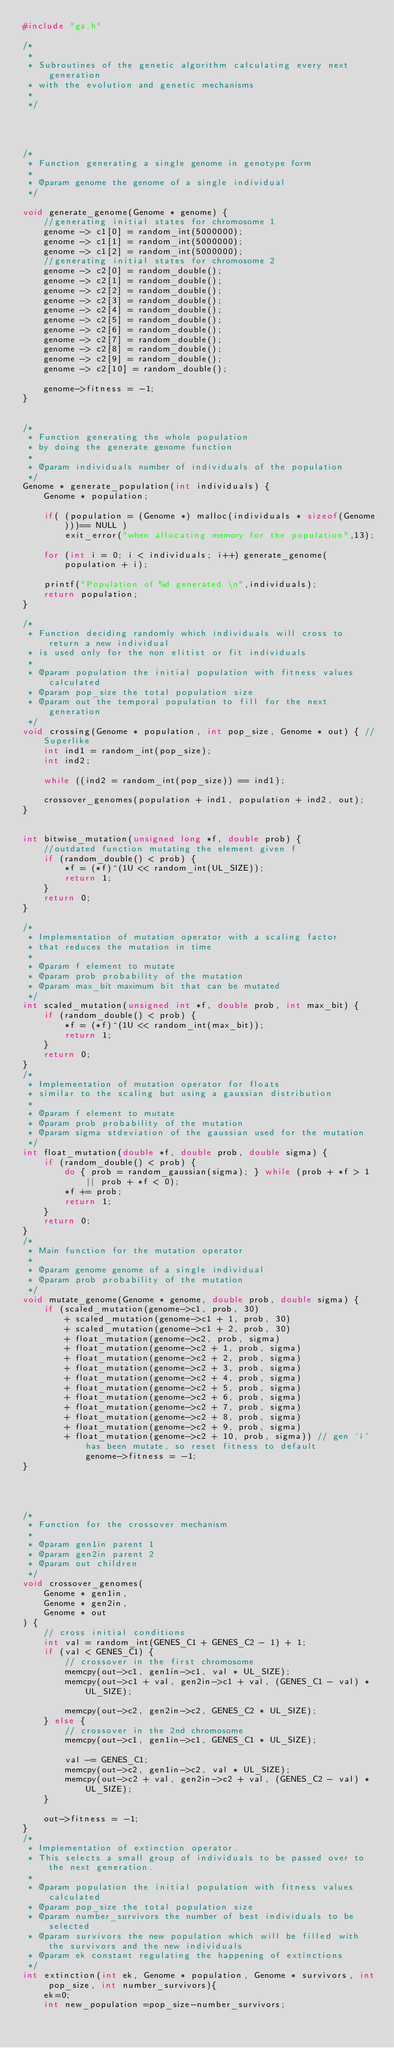Convert code to text. <code><loc_0><loc_0><loc_500><loc_500><_C_>#include "ga.h"

/*
 *
 * Subroutines of the genetic algorithm calculating every next generation
 * with the evolution and genetic mechanisms
 *
 */




/*
 * Function generating a single genome in genotype form
 *
 * @param genome the genome of a single individual
 */

void generate_genome(Genome * genome) {
	//generating initial states for chromosome 1
	genome -> c1[0] = random_int(5000000);
	genome -> c1[1] = random_int(5000000);
	genome -> c1[2] = random_int(5000000);
	//generating initial states for chromosome 2
	genome -> c2[0] = random_double();
	genome -> c2[1] = random_double();
	genome -> c2[2] = random_double();
	genome -> c2[3] = random_double();
	genome -> c2[4] = random_double();
	genome -> c2[5] = random_double();
	genome -> c2[6] = random_double();
	genome -> c2[7] = random_double();
	genome -> c2[8] = random_double();
	genome -> c2[9] = random_double();
	genome -> c2[10] = random_double();

	genome->fitness = -1;
}


/*
 * Function generating the whole population
 * by doing the generate genome function
 *
 * @param individuals number of individuals of the population
 */
Genome * generate_population(int individuals) {
	Genome * population;

	if( (population = (Genome *) malloc(individuals * sizeof(Genome)))== NULL )
		exit_error("when allocating memory for the population",13);

	for (int i = 0; i < individuals; i++) generate_genome(population + i);

	printf("Population of %d generated \n",individuals);
	return population;
}

/*
 * Function deciding randomly which individuals will cross to return a new individual
 * is used only for the non elitist or fit individuals
 *
 * @param population the initial population with fitness values calculated
 * @param pop_size the total population size
 * @param out the temporal population to fill for the next generation
 */
void crossing(Genome * population, int pop_size, Genome * out) { //Superlike
	int ind1 = random_int(pop_size);
	int ind2;

	while ((ind2 = random_int(pop_size)) == ind1);

	crossover_genomes(population + ind1, population + ind2, out);
}


int bitwise_mutation(unsigned long *f, double prob) {
	//outdated function mutating the element given f
	if (random_double() < prob) {
		*f = (*f)^(1U << random_int(UL_SIZE));
		return 1;
	}
	return 0;
}

/*
 * Implementation of mutation operator with a scaling factor
 * that reduces the mutation in time
 *
 * @param f element to mutate
 * @param prob probability of the mutation
 * @param max_bit maximum bit that can be mutated
 */
int scaled_mutation(unsigned int *f, double prob, int max_bit) {
	if (random_double() < prob) {
		*f = (*f)^(1U << random_int(max_bit));
		return 1;
	}
	return 0;
}
/*
 * Implementation of mutation operator for floats
 * similar to the scaling but using a gaussian distribution
 *
 * @param f element to mutate
 * @param prob probability of the mutation
 * @param sigma stdeviation of the gaussian used for the mutation
 */
int float_mutation(double *f, double prob, double sigma) {
	if (random_double() < prob) {
		do { prob = random_gaussian(sigma); } while (prob + *f > 1 || prob + *f < 0);
		*f += prob;
		return 1;
	}
	return 0;
}
/*
 * Main function for the mutation operator
 *
 * @param genome genome of a single individual
 * @param prob probability of the mutation
 */
void mutate_genome(Genome * genome, double prob, double sigma) {
	if (scaled_mutation(genome->c1, prob, 30)
		+ scaled_mutation(genome->c1 + 1, prob, 30)
		+ scaled_mutation(genome->c1 + 2, prob, 30)
		+ float_mutation(genome->c2, prob, sigma)
		+ float_mutation(genome->c2 + 1, prob, sigma)
		+ float_mutation(genome->c2 + 2, prob, sigma)
		+ float_mutation(genome->c2 + 3, prob, sigma)
		+ float_mutation(genome->c2 + 4, prob, sigma)
		+ float_mutation(genome->c2 + 5, prob, sigma)
		+ float_mutation(genome->c2 + 6, prob, sigma)
		+ float_mutation(genome->c2 + 7, prob, sigma)
		+ float_mutation(genome->c2 + 8, prob, sigma)
		+ float_mutation(genome->c2 + 9, prob, sigma)
		+ float_mutation(genome->c2 + 10, prob, sigma)) // gen `i` has been mutate, so reset fitness to default
			genome->fitness = -1;
}




/*
 * Function for the crossover mechanism
 *
 * @param gen1in parent 1
 * @param gen2in parent 2
 * @param out children
 */
void crossover_genomes(
	Genome * gen1in,
	Genome * gen2in,
	Genome * out
) {
	// cross initial conditions
	int val = random_int(GENES_C1 + GENES_C2 - 1) + 1;
	if (val < GENES_C1) {
		// crossover in the first chromosome
		memcpy(out->c1, gen1in->c1, val * UL_SIZE);
		memcpy(out->c1 + val, gen2in->c1 + val, (GENES_C1 - val) * UL_SIZE);

		memcpy(out->c2, gen2in->c2, GENES_C2 * UL_SIZE);
	} else {
		// crossover in the 2nd chromosome
		memcpy(out->c1, gen1in->c1, GENES_C1 * UL_SIZE);

		val -= GENES_C1;
		memcpy(out->c2, gen1in->c2, val * UL_SIZE);
		memcpy(out->c2 + val, gen2in->c2 + val, (GENES_C2 - val) * UL_SIZE);
	}

	out->fitness = -1;
}
/*
 * Implementation of extinction operator.
 * This selects a small group of individuals to be passed over to the next generation.
 *
 * @param population the initial population with fitness values calculated
 * @param pop_size the total population size
 * @param number_survivors the number of best individuals to be selected
 * @param survivors the new population which will be filled with the survivors and the new individuals
 * @param ek constant regulating the happening of extinctions
 */
int extinction(int ek, Genome * population, Genome * survivors, int pop_size, int number_survivors){
	ek=0;
	int new_population =pop_size-number_survivors;
</code> 